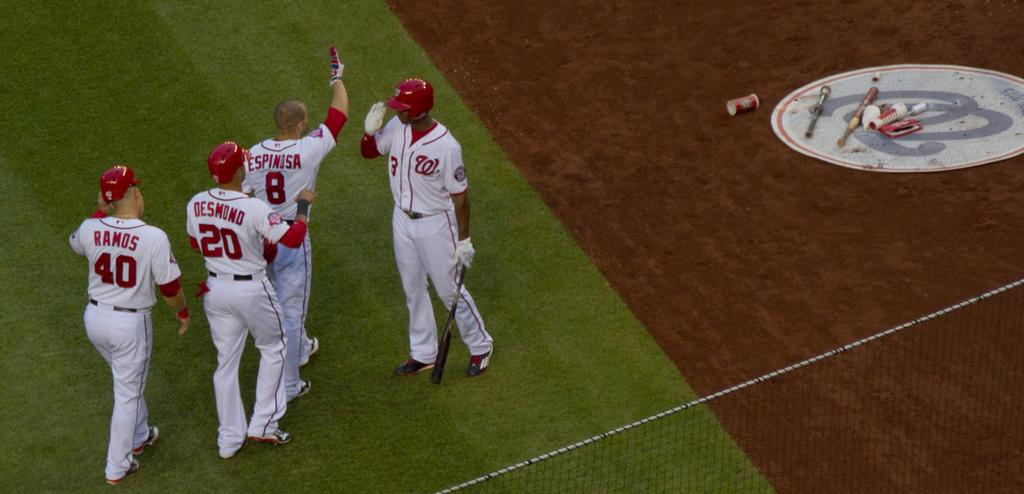Provide a one-sentence caption for the provided image. Ball players named Desmond and Ramos wear the 20 and 40 uniforms respectively. 